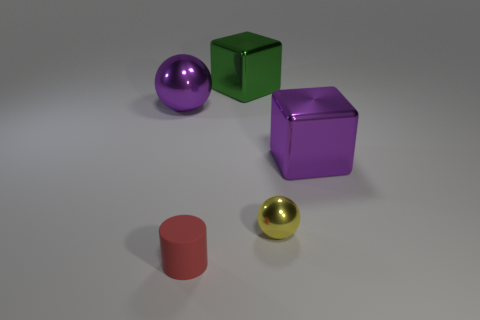Are there any other things that are made of the same material as the cylinder?
Give a very brief answer. No. The small cylinder that is in front of the big purple shiny thing on the right side of the yellow metallic object that is behind the small red thing is made of what material?
Your response must be concise. Rubber. How many big things are green blocks or yellow metallic objects?
Give a very brief answer. 1. How many other things are the same size as the cylinder?
Ensure brevity in your answer.  1. There is a shiny thing behind the big sphere; does it have the same shape as the tiny metal thing?
Your answer should be compact. No. What is the color of the other big object that is the same shape as the big green object?
Your answer should be compact. Purple. Is there any other thing that has the same shape as the red thing?
Your answer should be compact. No. Are there the same number of shiny cubes on the right side of the purple cube and blue blocks?
Your answer should be very brief. Yes. How many shiny things are in front of the purple cube and left of the yellow metal object?
Your answer should be very brief. 0. How many green objects have the same material as the purple block?
Your answer should be very brief. 1. 